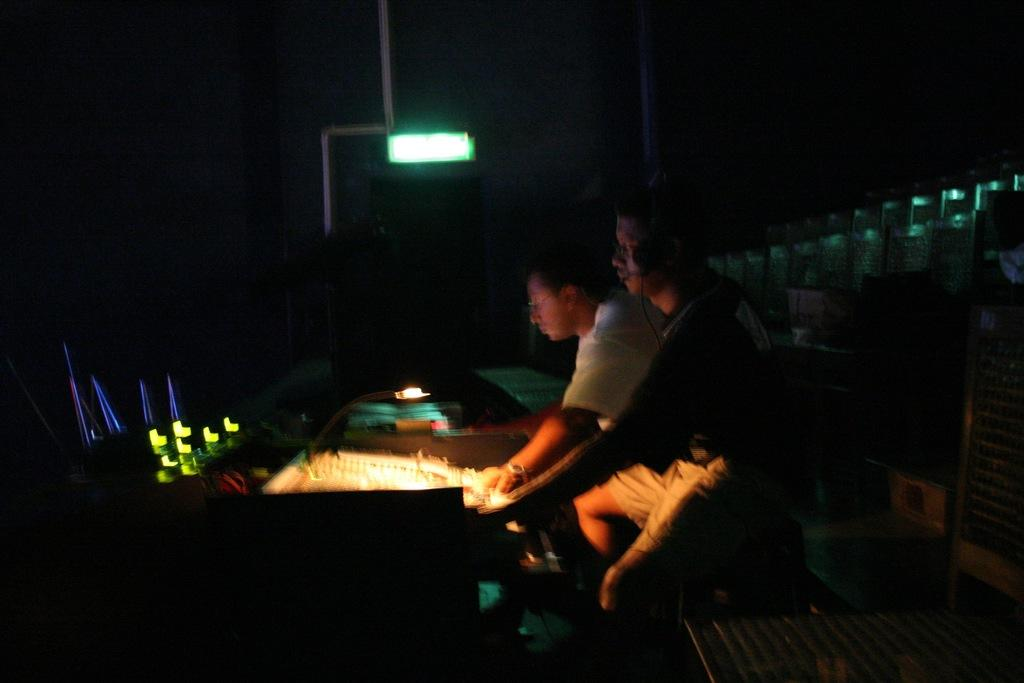How many people are in the image? There are two persons in the image. What are the two persons doing in the image? The two persons are sitting at equipment. What can be seen in the background of the image? There is a light and a wall in the background of the image. What is the size of the chin of the person on the left in the image? There is no chin visible in the image, as the faces of the two persons are not shown. 